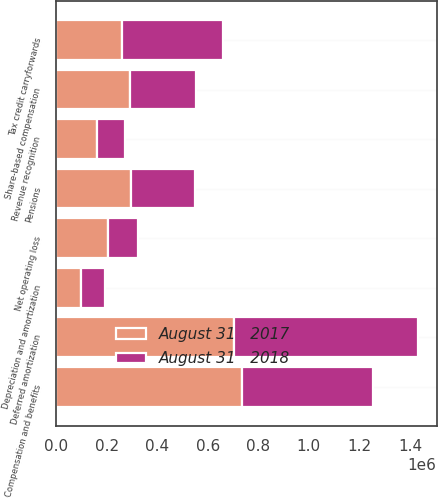Convert chart to OTSL. <chart><loc_0><loc_0><loc_500><loc_500><stacked_bar_chart><ecel><fcel>Pensions<fcel>Revenue recognition<fcel>Compensation and benefits<fcel>Share-based compensation<fcel>Tax credit carryforwards<fcel>Net operating loss<fcel>Depreciation and amortization<fcel>Deferred amortization<nl><fcel>August 31   2018<fcel>254268<fcel>110424<fcel>517850<fcel>259276<fcel>400253<fcel>119130<fcel>97459<fcel>728564<nl><fcel>August 31   2017<fcel>294850<fcel>163393<fcel>734373<fcel>293546<fcel>259276<fcel>204803<fcel>97076<fcel>705495<nl></chart> 